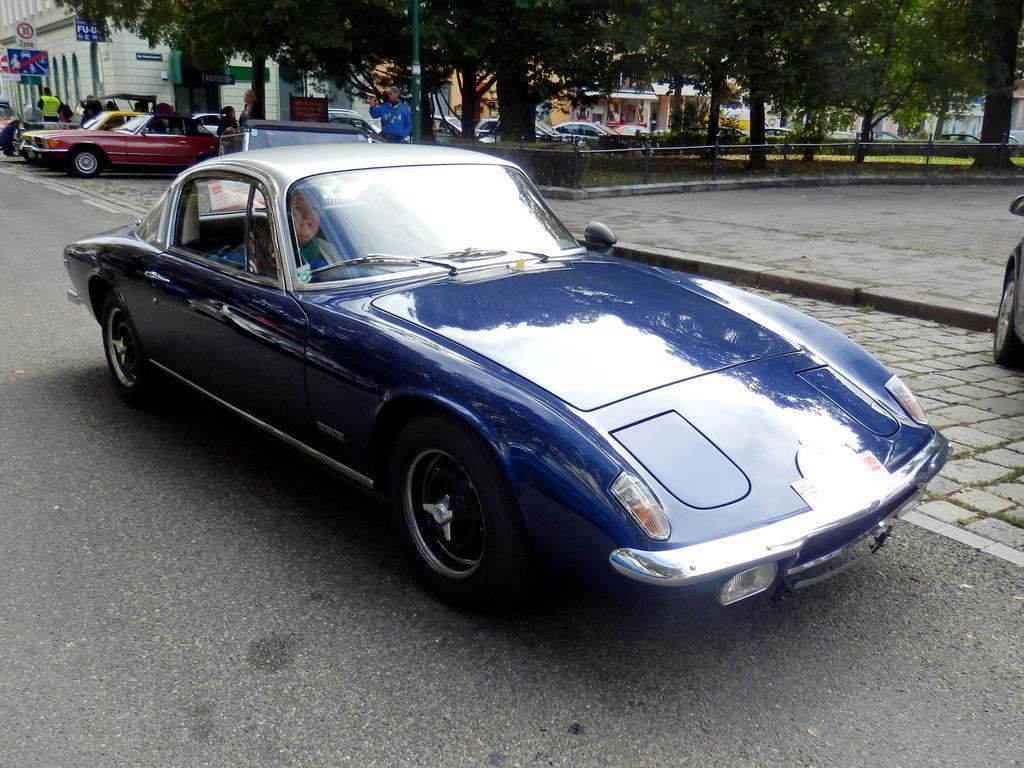Can you describe this image briefly? In the image there is a blue car with a lady inside it on the road, behind it there are few other cars on the footpath under the trees followed by buildings in the background. 